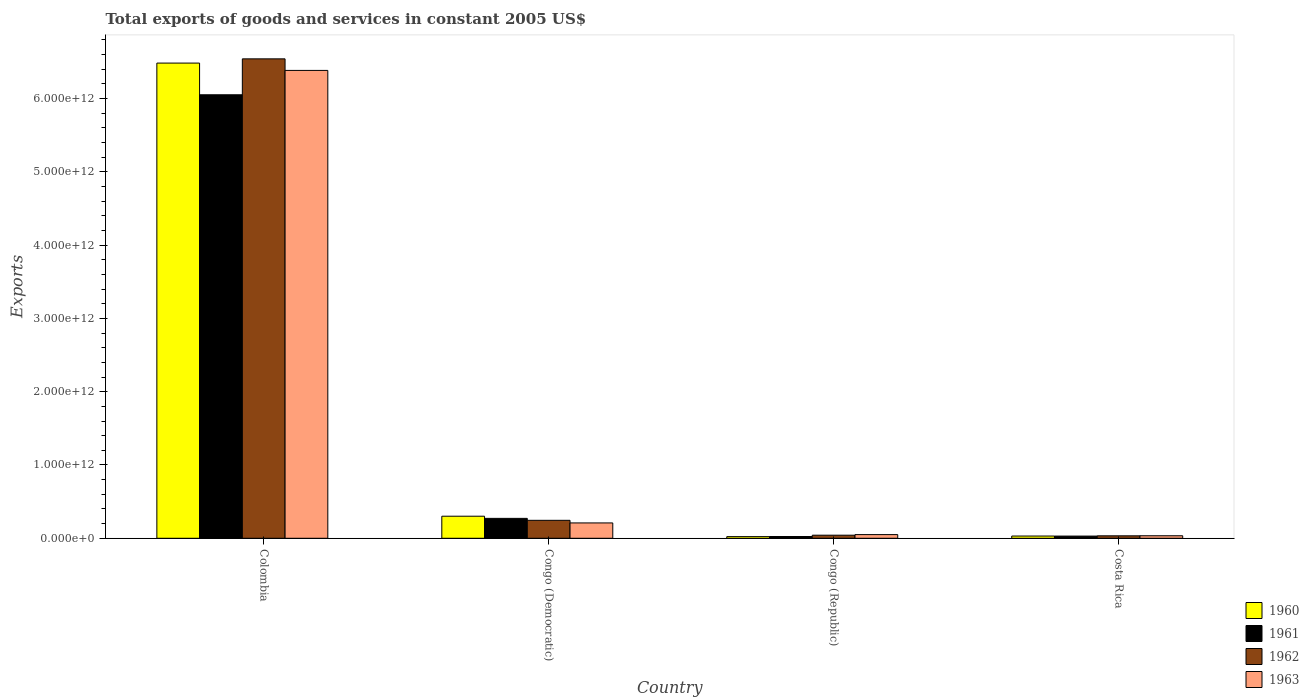How many different coloured bars are there?
Give a very brief answer. 4. How many groups of bars are there?
Provide a short and direct response. 4. What is the total exports of goods and services in 1963 in Costa Rica?
Provide a succinct answer. 3.44e+1. Across all countries, what is the maximum total exports of goods and services in 1963?
Provide a short and direct response. 6.38e+12. Across all countries, what is the minimum total exports of goods and services in 1960?
Offer a very short reply. 2.25e+1. In which country was the total exports of goods and services in 1962 maximum?
Make the answer very short. Colombia. In which country was the total exports of goods and services in 1961 minimum?
Give a very brief answer. Congo (Republic). What is the total total exports of goods and services in 1962 in the graph?
Provide a succinct answer. 6.86e+12. What is the difference between the total exports of goods and services in 1963 in Colombia and that in Congo (Republic)?
Keep it short and to the point. 6.33e+12. What is the difference between the total exports of goods and services in 1962 in Congo (Republic) and the total exports of goods and services in 1963 in Costa Rica?
Offer a very short reply. 7.66e+09. What is the average total exports of goods and services in 1961 per country?
Provide a succinct answer. 1.59e+12. What is the difference between the total exports of goods and services of/in 1960 and total exports of goods and services of/in 1963 in Congo (Republic)?
Ensure brevity in your answer.  -2.76e+1. In how many countries, is the total exports of goods and services in 1963 greater than 6200000000000 US$?
Your answer should be very brief. 1. What is the ratio of the total exports of goods and services in 1960 in Colombia to that in Congo (Democratic)?
Offer a terse response. 21.53. Is the total exports of goods and services in 1963 in Colombia less than that in Congo (Democratic)?
Make the answer very short. No. What is the difference between the highest and the second highest total exports of goods and services in 1962?
Keep it short and to the point. -6.30e+12. What is the difference between the highest and the lowest total exports of goods and services in 1960?
Make the answer very short. 6.46e+12. In how many countries, is the total exports of goods and services in 1962 greater than the average total exports of goods and services in 1962 taken over all countries?
Make the answer very short. 1. What does the 1st bar from the left in Costa Rica represents?
Make the answer very short. 1960. Is it the case that in every country, the sum of the total exports of goods and services in 1960 and total exports of goods and services in 1962 is greater than the total exports of goods and services in 1961?
Give a very brief answer. Yes. What is the difference between two consecutive major ticks on the Y-axis?
Your answer should be very brief. 1.00e+12. Are the values on the major ticks of Y-axis written in scientific E-notation?
Provide a short and direct response. Yes. Does the graph contain any zero values?
Your response must be concise. No. Does the graph contain grids?
Keep it short and to the point. No. Where does the legend appear in the graph?
Your response must be concise. Bottom right. What is the title of the graph?
Ensure brevity in your answer.  Total exports of goods and services in constant 2005 US$. Does "2012" appear as one of the legend labels in the graph?
Offer a very short reply. No. What is the label or title of the Y-axis?
Provide a short and direct response. Exports. What is the Exports in 1960 in Colombia?
Ensure brevity in your answer.  6.48e+12. What is the Exports of 1961 in Colombia?
Your answer should be very brief. 6.05e+12. What is the Exports of 1962 in Colombia?
Your answer should be compact. 6.54e+12. What is the Exports of 1963 in Colombia?
Your answer should be very brief. 6.38e+12. What is the Exports in 1960 in Congo (Democratic)?
Offer a very short reply. 3.01e+11. What is the Exports in 1961 in Congo (Democratic)?
Provide a succinct answer. 2.72e+11. What is the Exports in 1962 in Congo (Democratic)?
Give a very brief answer. 2.45e+11. What is the Exports of 1963 in Congo (Democratic)?
Make the answer very short. 2.09e+11. What is the Exports of 1960 in Congo (Republic)?
Give a very brief answer. 2.25e+1. What is the Exports in 1961 in Congo (Republic)?
Give a very brief answer. 2.42e+1. What is the Exports in 1962 in Congo (Republic)?
Provide a succinct answer. 4.20e+1. What is the Exports in 1963 in Congo (Republic)?
Keep it short and to the point. 5.01e+1. What is the Exports in 1960 in Costa Rica?
Your answer should be very brief. 3.05e+1. What is the Exports in 1961 in Costa Rica?
Give a very brief answer. 3.00e+1. What is the Exports of 1962 in Costa Rica?
Your response must be concise. 3.35e+1. What is the Exports in 1963 in Costa Rica?
Keep it short and to the point. 3.44e+1. Across all countries, what is the maximum Exports of 1960?
Give a very brief answer. 6.48e+12. Across all countries, what is the maximum Exports in 1961?
Offer a terse response. 6.05e+12. Across all countries, what is the maximum Exports of 1962?
Your answer should be compact. 6.54e+12. Across all countries, what is the maximum Exports of 1963?
Your answer should be very brief. 6.38e+12. Across all countries, what is the minimum Exports in 1960?
Give a very brief answer. 2.25e+1. Across all countries, what is the minimum Exports of 1961?
Provide a short and direct response. 2.42e+1. Across all countries, what is the minimum Exports of 1962?
Offer a very short reply. 3.35e+1. Across all countries, what is the minimum Exports in 1963?
Your answer should be very brief. 3.44e+1. What is the total Exports of 1960 in the graph?
Provide a short and direct response. 6.84e+12. What is the total Exports of 1961 in the graph?
Offer a terse response. 6.38e+12. What is the total Exports of 1962 in the graph?
Offer a terse response. 6.86e+12. What is the total Exports in 1963 in the graph?
Your answer should be very brief. 6.68e+12. What is the difference between the Exports of 1960 in Colombia and that in Congo (Democratic)?
Provide a succinct answer. 6.18e+12. What is the difference between the Exports of 1961 in Colombia and that in Congo (Democratic)?
Keep it short and to the point. 5.78e+12. What is the difference between the Exports of 1962 in Colombia and that in Congo (Democratic)?
Offer a terse response. 6.30e+12. What is the difference between the Exports of 1963 in Colombia and that in Congo (Democratic)?
Give a very brief answer. 6.17e+12. What is the difference between the Exports of 1960 in Colombia and that in Congo (Republic)?
Your answer should be compact. 6.46e+12. What is the difference between the Exports in 1961 in Colombia and that in Congo (Republic)?
Make the answer very short. 6.03e+12. What is the difference between the Exports in 1962 in Colombia and that in Congo (Republic)?
Offer a very short reply. 6.50e+12. What is the difference between the Exports in 1963 in Colombia and that in Congo (Republic)?
Keep it short and to the point. 6.33e+12. What is the difference between the Exports of 1960 in Colombia and that in Costa Rica?
Provide a succinct answer. 6.45e+12. What is the difference between the Exports of 1961 in Colombia and that in Costa Rica?
Your answer should be compact. 6.02e+12. What is the difference between the Exports in 1962 in Colombia and that in Costa Rica?
Provide a succinct answer. 6.51e+12. What is the difference between the Exports in 1963 in Colombia and that in Costa Rica?
Your answer should be very brief. 6.35e+12. What is the difference between the Exports in 1960 in Congo (Democratic) and that in Congo (Republic)?
Make the answer very short. 2.79e+11. What is the difference between the Exports in 1961 in Congo (Democratic) and that in Congo (Republic)?
Ensure brevity in your answer.  2.48e+11. What is the difference between the Exports in 1962 in Congo (Democratic) and that in Congo (Republic)?
Your answer should be compact. 2.03e+11. What is the difference between the Exports of 1963 in Congo (Democratic) and that in Congo (Republic)?
Offer a terse response. 1.59e+11. What is the difference between the Exports of 1960 in Congo (Democratic) and that in Costa Rica?
Make the answer very short. 2.71e+11. What is the difference between the Exports in 1961 in Congo (Democratic) and that in Costa Rica?
Your answer should be very brief. 2.42e+11. What is the difference between the Exports of 1962 in Congo (Democratic) and that in Costa Rica?
Make the answer very short. 2.11e+11. What is the difference between the Exports of 1963 in Congo (Democratic) and that in Costa Rica?
Offer a terse response. 1.75e+11. What is the difference between the Exports of 1960 in Congo (Republic) and that in Costa Rica?
Provide a short and direct response. -7.99e+09. What is the difference between the Exports in 1961 in Congo (Republic) and that in Costa Rica?
Provide a short and direct response. -5.74e+09. What is the difference between the Exports of 1962 in Congo (Republic) and that in Costa Rica?
Offer a very short reply. 8.51e+09. What is the difference between the Exports of 1963 in Congo (Republic) and that in Costa Rica?
Provide a short and direct response. 1.57e+1. What is the difference between the Exports in 1960 in Colombia and the Exports in 1961 in Congo (Democratic)?
Provide a succinct answer. 6.21e+12. What is the difference between the Exports in 1960 in Colombia and the Exports in 1962 in Congo (Democratic)?
Offer a very short reply. 6.24e+12. What is the difference between the Exports of 1960 in Colombia and the Exports of 1963 in Congo (Democratic)?
Your answer should be very brief. 6.27e+12. What is the difference between the Exports in 1961 in Colombia and the Exports in 1962 in Congo (Democratic)?
Provide a short and direct response. 5.81e+12. What is the difference between the Exports of 1961 in Colombia and the Exports of 1963 in Congo (Democratic)?
Offer a terse response. 5.84e+12. What is the difference between the Exports of 1962 in Colombia and the Exports of 1963 in Congo (Democratic)?
Your answer should be compact. 6.33e+12. What is the difference between the Exports in 1960 in Colombia and the Exports in 1961 in Congo (Republic)?
Your response must be concise. 6.46e+12. What is the difference between the Exports of 1960 in Colombia and the Exports of 1962 in Congo (Republic)?
Make the answer very short. 6.44e+12. What is the difference between the Exports of 1960 in Colombia and the Exports of 1963 in Congo (Republic)?
Make the answer very short. 6.43e+12. What is the difference between the Exports of 1961 in Colombia and the Exports of 1962 in Congo (Republic)?
Make the answer very short. 6.01e+12. What is the difference between the Exports of 1961 in Colombia and the Exports of 1963 in Congo (Republic)?
Provide a short and direct response. 6.00e+12. What is the difference between the Exports in 1962 in Colombia and the Exports in 1963 in Congo (Republic)?
Your answer should be very brief. 6.49e+12. What is the difference between the Exports in 1960 in Colombia and the Exports in 1961 in Costa Rica?
Make the answer very short. 6.45e+12. What is the difference between the Exports in 1960 in Colombia and the Exports in 1962 in Costa Rica?
Your answer should be very brief. 6.45e+12. What is the difference between the Exports of 1960 in Colombia and the Exports of 1963 in Costa Rica?
Provide a short and direct response. 6.45e+12. What is the difference between the Exports in 1961 in Colombia and the Exports in 1962 in Costa Rica?
Ensure brevity in your answer.  6.02e+12. What is the difference between the Exports in 1961 in Colombia and the Exports in 1963 in Costa Rica?
Offer a terse response. 6.02e+12. What is the difference between the Exports in 1962 in Colombia and the Exports in 1963 in Costa Rica?
Give a very brief answer. 6.51e+12. What is the difference between the Exports of 1960 in Congo (Democratic) and the Exports of 1961 in Congo (Republic)?
Provide a short and direct response. 2.77e+11. What is the difference between the Exports in 1960 in Congo (Democratic) and the Exports in 1962 in Congo (Republic)?
Ensure brevity in your answer.  2.59e+11. What is the difference between the Exports of 1960 in Congo (Democratic) and the Exports of 1963 in Congo (Republic)?
Offer a very short reply. 2.51e+11. What is the difference between the Exports in 1961 in Congo (Democratic) and the Exports in 1962 in Congo (Republic)?
Your answer should be very brief. 2.30e+11. What is the difference between the Exports in 1961 in Congo (Democratic) and the Exports in 1963 in Congo (Republic)?
Your answer should be very brief. 2.22e+11. What is the difference between the Exports of 1962 in Congo (Democratic) and the Exports of 1963 in Congo (Republic)?
Offer a terse response. 1.95e+11. What is the difference between the Exports in 1960 in Congo (Democratic) and the Exports in 1961 in Costa Rica?
Your answer should be very brief. 2.71e+11. What is the difference between the Exports in 1960 in Congo (Democratic) and the Exports in 1962 in Costa Rica?
Keep it short and to the point. 2.68e+11. What is the difference between the Exports of 1960 in Congo (Democratic) and the Exports of 1963 in Costa Rica?
Provide a succinct answer. 2.67e+11. What is the difference between the Exports in 1961 in Congo (Democratic) and the Exports in 1962 in Costa Rica?
Your response must be concise. 2.38e+11. What is the difference between the Exports of 1961 in Congo (Democratic) and the Exports of 1963 in Costa Rica?
Keep it short and to the point. 2.37e+11. What is the difference between the Exports of 1962 in Congo (Democratic) and the Exports of 1963 in Costa Rica?
Your response must be concise. 2.11e+11. What is the difference between the Exports in 1960 in Congo (Republic) and the Exports in 1961 in Costa Rica?
Your response must be concise. -7.43e+09. What is the difference between the Exports of 1960 in Congo (Republic) and the Exports of 1962 in Costa Rica?
Offer a very short reply. -1.10e+1. What is the difference between the Exports in 1960 in Congo (Republic) and the Exports in 1963 in Costa Rica?
Provide a short and direct response. -1.19e+1. What is the difference between the Exports of 1961 in Congo (Republic) and the Exports of 1962 in Costa Rica?
Provide a short and direct response. -9.32e+09. What is the difference between the Exports of 1961 in Congo (Republic) and the Exports of 1963 in Costa Rica?
Your answer should be very brief. -1.02e+1. What is the difference between the Exports in 1962 in Congo (Republic) and the Exports in 1963 in Costa Rica?
Your answer should be compact. 7.66e+09. What is the average Exports of 1960 per country?
Provide a short and direct response. 1.71e+12. What is the average Exports of 1961 per country?
Offer a very short reply. 1.59e+12. What is the average Exports in 1962 per country?
Provide a succinct answer. 1.72e+12. What is the average Exports of 1963 per country?
Keep it short and to the point. 1.67e+12. What is the difference between the Exports of 1960 and Exports of 1961 in Colombia?
Provide a succinct answer. 4.32e+11. What is the difference between the Exports in 1960 and Exports in 1962 in Colombia?
Provide a short and direct response. -5.79e+1. What is the difference between the Exports of 1960 and Exports of 1963 in Colombia?
Provide a succinct answer. 1.00e+11. What is the difference between the Exports in 1961 and Exports in 1962 in Colombia?
Provide a succinct answer. -4.90e+11. What is the difference between the Exports of 1961 and Exports of 1963 in Colombia?
Keep it short and to the point. -3.32e+11. What is the difference between the Exports in 1962 and Exports in 1963 in Colombia?
Provide a short and direct response. 1.58e+11. What is the difference between the Exports of 1960 and Exports of 1961 in Congo (Democratic)?
Ensure brevity in your answer.  2.94e+1. What is the difference between the Exports in 1960 and Exports in 1962 in Congo (Democratic)?
Provide a short and direct response. 5.61e+1. What is the difference between the Exports in 1960 and Exports in 1963 in Congo (Democratic)?
Provide a succinct answer. 9.17e+1. What is the difference between the Exports of 1961 and Exports of 1962 in Congo (Democratic)?
Your response must be concise. 2.67e+1. What is the difference between the Exports of 1961 and Exports of 1963 in Congo (Democratic)?
Ensure brevity in your answer.  6.23e+1. What is the difference between the Exports in 1962 and Exports in 1963 in Congo (Democratic)?
Provide a succinct answer. 3.56e+1. What is the difference between the Exports of 1960 and Exports of 1961 in Congo (Republic)?
Your answer should be compact. -1.69e+09. What is the difference between the Exports in 1960 and Exports in 1962 in Congo (Republic)?
Offer a very short reply. -1.95e+1. What is the difference between the Exports in 1960 and Exports in 1963 in Congo (Republic)?
Ensure brevity in your answer.  -2.76e+1. What is the difference between the Exports in 1961 and Exports in 1962 in Congo (Republic)?
Offer a very short reply. -1.78e+1. What is the difference between the Exports of 1961 and Exports of 1963 in Congo (Republic)?
Ensure brevity in your answer.  -2.59e+1. What is the difference between the Exports of 1962 and Exports of 1963 in Congo (Republic)?
Provide a short and direct response. -8.07e+09. What is the difference between the Exports in 1960 and Exports in 1961 in Costa Rica?
Give a very brief answer. 5.60e+08. What is the difference between the Exports in 1960 and Exports in 1962 in Costa Rica?
Give a very brief answer. -3.02e+09. What is the difference between the Exports in 1960 and Exports in 1963 in Costa Rica?
Offer a very short reply. -3.87e+09. What is the difference between the Exports of 1961 and Exports of 1962 in Costa Rica?
Provide a short and direct response. -3.58e+09. What is the difference between the Exports of 1961 and Exports of 1963 in Costa Rica?
Provide a short and direct response. -4.43e+09. What is the difference between the Exports in 1962 and Exports in 1963 in Costa Rica?
Offer a very short reply. -8.49e+08. What is the ratio of the Exports in 1960 in Colombia to that in Congo (Democratic)?
Offer a terse response. 21.53. What is the ratio of the Exports in 1961 in Colombia to that in Congo (Democratic)?
Offer a terse response. 22.27. What is the ratio of the Exports in 1962 in Colombia to that in Congo (Democratic)?
Give a very brief answer. 26.7. What is the ratio of the Exports of 1963 in Colombia to that in Congo (Democratic)?
Make the answer very short. 30.48. What is the ratio of the Exports of 1960 in Colombia to that in Congo (Republic)?
Provide a succinct answer. 287.84. What is the ratio of the Exports of 1961 in Colombia to that in Congo (Republic)?
Provide a succinct answer. 249.91. What is the ratio of the Exports of 1962 in Colombia to that in Congo (Republic)?
Ensure brevity in your answer.  155.58. What is the ratio of the Exports of 1963 in Colombia to that in Congo (Republic)?
Give a very brief answer. 127.37. What is the ratio of the Exports in 1960 in Colombia to that in Costa Rica?
Keep it short and to the point. 212.46. What is the ratio of the Exports of 1961 in Colombia to that in Costa Rica?
Provide a short and direct response. 202. What is the ratio of the Exports in 1962 in Colombia to that in Costa Rica?
Keep it short and to the point. 195.05. What is the ratio of the Exports in 1963 in Colombia to that in Costa Rica?
Ensure brevity in your answer.  185.65. What is the ratio of the Exports of 1960 in Congo (Democratic) to that in Congo (Republic)?
Your answer should be compact. 13.37. What is the ratio of the Exports in 1961 in Congo (Democratic) to that in Congo (Republic)?
Keep it short and to the point. 11.22. What is the ratio of the Exports in 1962 in Congo (Democratic) to that in Congo (Republic)?
Offer a terse response. 5.83. What is the ratio of the Exports in 1963 in Congo (Democratic) to that in Congo (Republic)?
Provide a succinct answer. 4.18. What is the ratio of the Exports in 1960 in Congo (Democratic) to that in Costa Rica?
Give a very brief answer. 9.87. What is the ratio of the Exports of 1961 in Congo (Democratic) to that in Costa Rica?
Make the answer very short. 9.07. What is the ratio of the Exports of 1962 in Congo (Democratic) to that in Costa Rica?
Your answer should be compact. 7.31. What is the ratio of the Exports of 1963 in Congo (Democratic) to that in Costa Rica?
Your response must be concise. 6.09. What is the ratio of the Exports in 1960 in Congo (Republic) to that in Costa Rica?
Ensure brevity in your answer.  0.74. What is the ratio of the Exports in 1961 in Congo (Republic) to that in Costa Rica?
Your answer should be compact. 0.81. What is the ratio of the Exports in 1962 in Congo (Republic) to that in Costa Rica?
Make the answer very short. 1.25. What is the ratio of the Exports in 1963 in Congo (Republic) to that in Costa Rica?
Your answer should be compact. 1.46. What is the difference between the highest and the second highest Exports in 1960?
Your answer should be compact. 6.18e+12. What is the difference between the highest and the second highest Exports of 1961?
Provide a succinct answer. 5.78e+12. What is the difference between the highest and the second highest Exports of 1962?
Offer a terse response. 6.30e+12. What is the difference between the highest and the second highest Exports in 1963?
Your answer should be compact. 6.17e+12. What is the difference between the highest and the lowest Exports of 1960?
Offer a very short reply. 6.46e+12. What is the difference between the highest and the lowest Exports of 1961?
Provide a short and direct response. 6.03e+12. What is the difference between the highest and the lowest Exports of 1962?
Your answer should be compact. 6.51e+12. What is the difference between the highest and the lowest Exports of 1963?
Ensure brevity in your answer.  6.35e+12. 